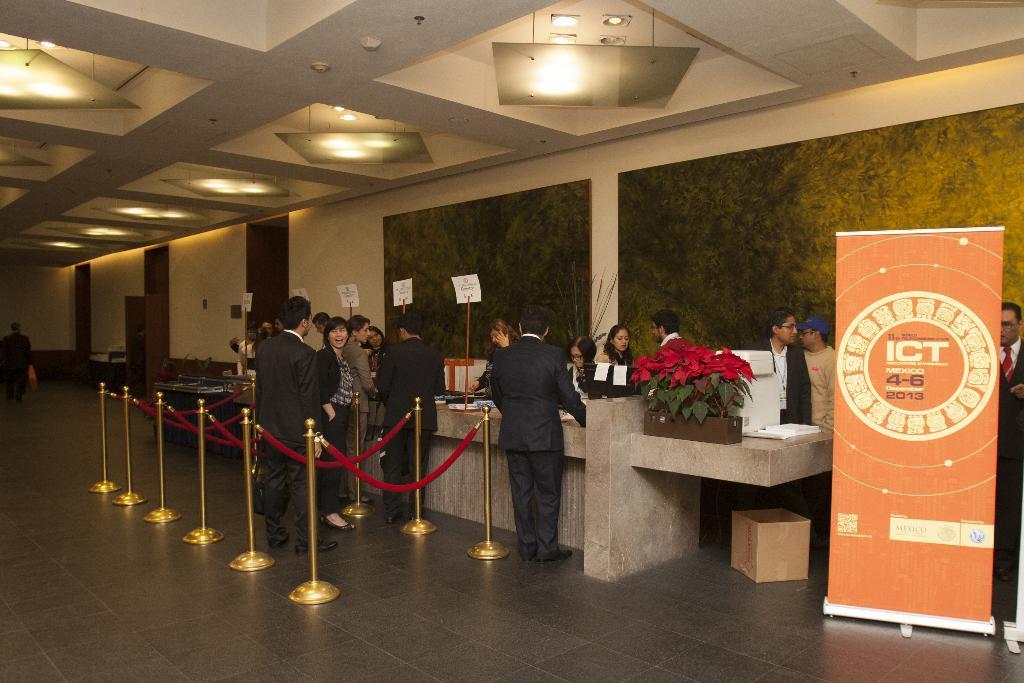How would you summarize this image in a sentence or two? This image consists of many people standing near the reception. At the bottom, there is a floor. In the background, there is a wall. At the top, there is a roof along with light. 